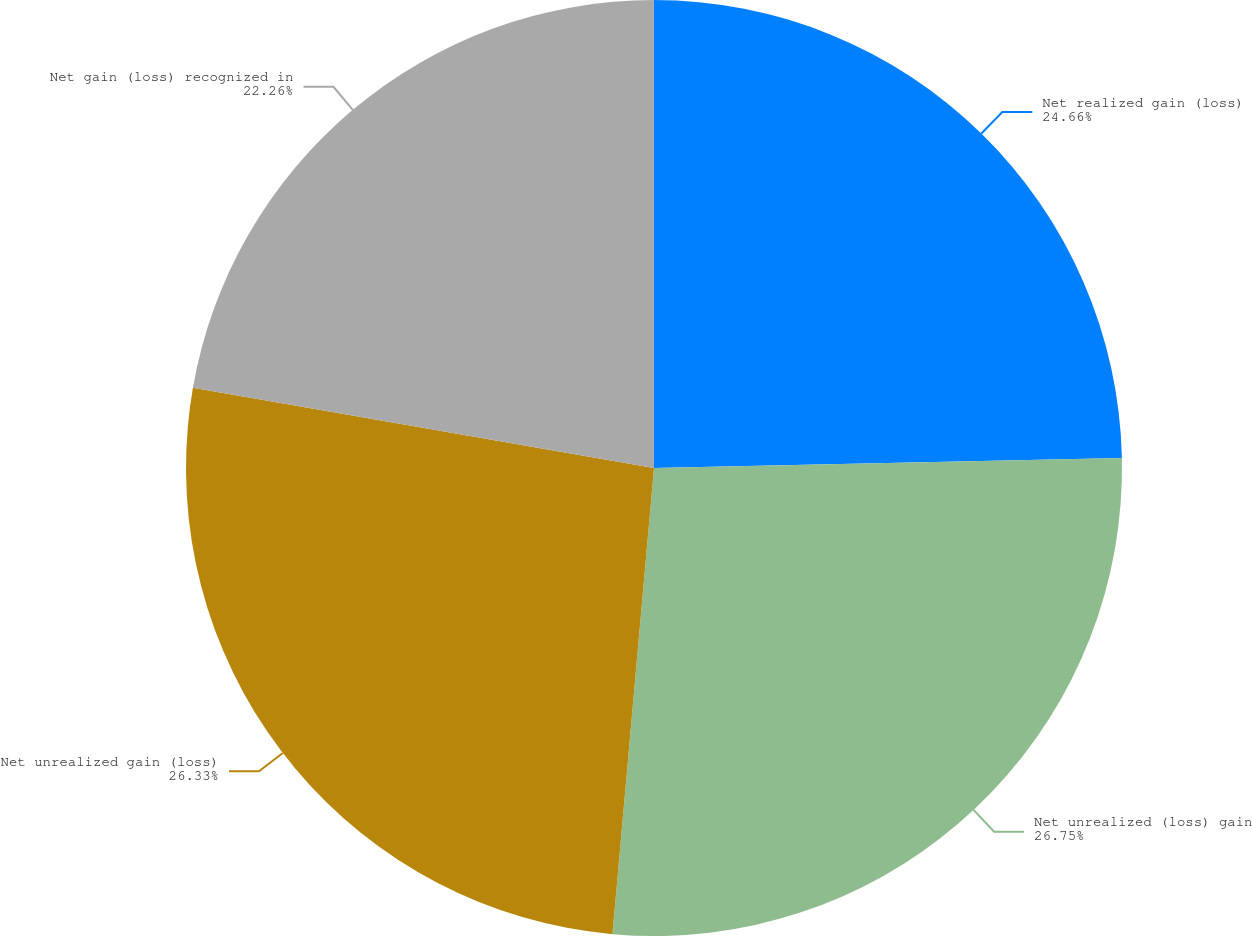Convert chart. <chart><loc_0><loc_0><loc_500><loc_500><pie_chart><fcel>Net realized gain (loss)<fcel>Net unrealized (loss) gain<fcel>Net unrealized gain (loss)<fcel>Net gain (loss) recognized in<nl><fcel>24.66%<fcel>26.76%<fcel>26.33%<fcel>22.26%<nl></chart> 